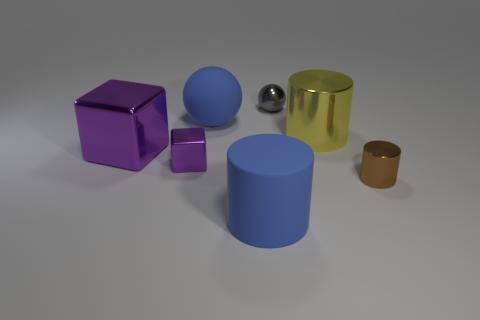Do the large matte sphere and the big rubber cylinder have the same color?
Your response must be concise. Yes. What material is the small object that is behind the blue matte sphere?
Keep it short and to the point. Metal. What number of tiny objects are red rubber blocks or brown shiny things?
Your response must be concise. 1. There is a big cube that is the same color as the tiny cube; what is it made of?
Provide a succinct answer. Metal. Are there any balls that have the same material as the big blue cylinder?
Provide a short and direct response. Yes. Does the sphere that is left of the blue rubber cylinder have the same size as the gray metallic thing?
Make the answer very short. No. There is a gray shiny sphere that is on the right side of the big cylinder in front of the brown metal cylinder; are there any large blue matte spheres on the left side of it?
Provide a short and direct response. Yes. How many shiny objects are either big yellow cylinders or tiny purple cubes?
Offer a very short reply. 2. How many other objects are there of the same shape as the large purple thing?
Make the answer very short. 1. Is the number of blue balls greater than the number of blue matte things?
Ensure brevity in your answer.  No. 